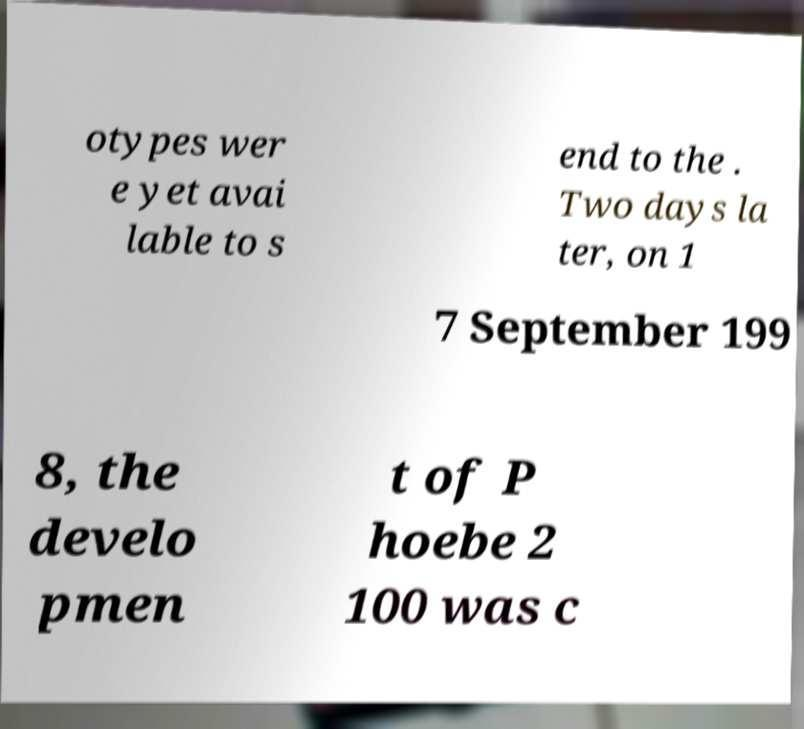I need the written content from this picture converted into text. Can you do that? otypes wer e yet avai lable to s end to the . Two days la ter, on 1 7 September 199 8, the develo pmen t of P hoebe 2 100 was c 